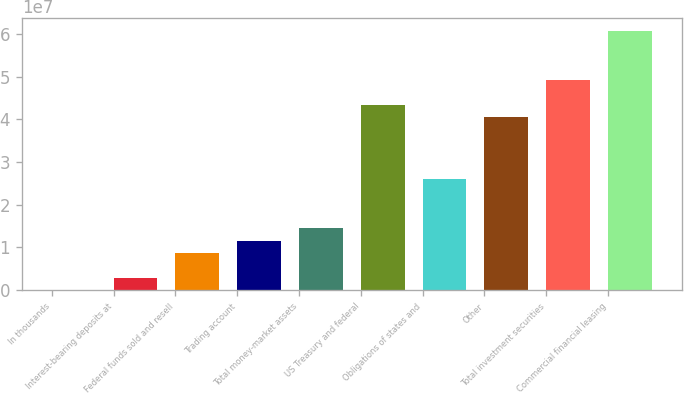Convert chart. <chart><loc_0><loc_0><loc_500><loc_500><bar_chart><fcel>In thousands<fcel>Interest-bearing deposits at<fcel>Federal funds sold and resell<fcel>Trading account<fcel>Total money-market assets<fcel>US Treasury and federal<fcel>Obligations of states and<fcel>Other<fcel>Total investment securities<fcel>Commercial financial leasing<nl><fcel>2000<fcel>2.89818e+06<fcel>8.69054e+06<fcel>1.15867e+07<fcel>1.44829e+07<fcel>4.34447e+07<fcel>2.60676e+07<fcel>4.05485e+07<fcel>4.9237e+07<fcel>6.08217e+07<nl></chart> 